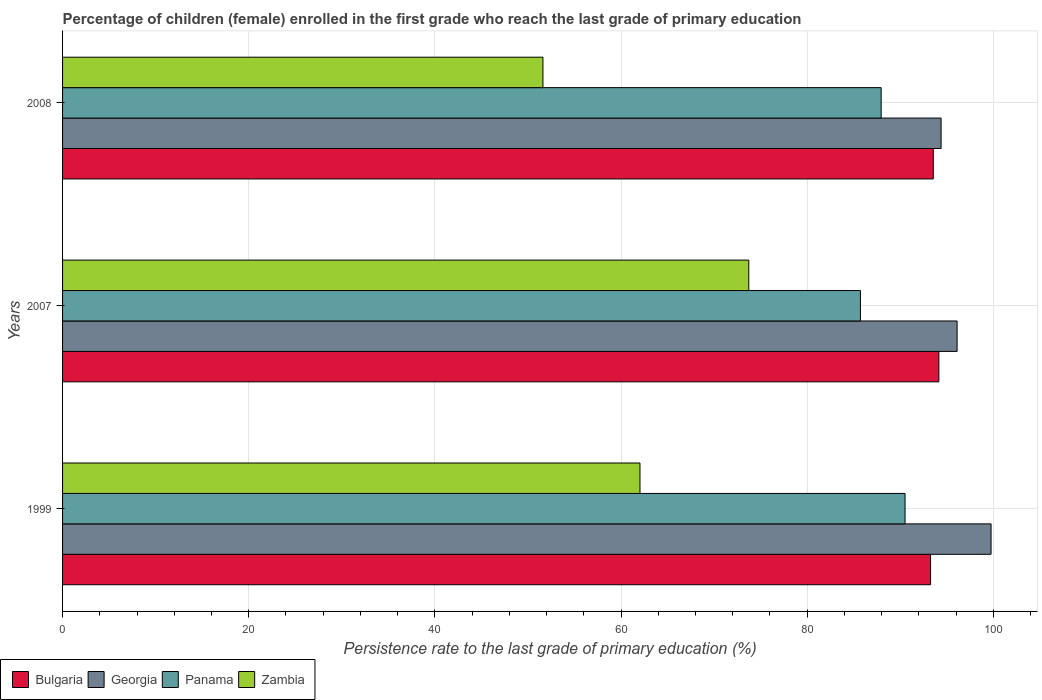How many different coloured bars are there?
Provide a short and direct response. 4. Are the number of bars on each tick of the Y-axis equal?
Ensure brevity in your answer.  Yes. How many bars are there on the 1st tick from the bottom?
Ensure brevity in your answer.  4. What is the label of the 3rd group of bars from the top?
Your answer should be compact. 1999. What is the persistence rate of children in Panama in 1999?
Give a very brief answer. 90.51. Across all years, what is the maximum persistence rate of children in Zambia?
Provide a short and direct response. 73.72. Across all years, what is the minimum persistence rate of children in Bulgaria?
Give a very brief answer. 93.25. What is the total persistence rate of children in Zambia in the graph?
Your answer should be very brief. 187.37. What is the difference between the persistence rate of children in Bulgaria in 1999 and that in 2007?
Your answer should be very brief. -0.89. What is the difference between the persistence rate of children in Bulgaria in 2008 and the persistence rate of children in Panama in 2007?
Offer a very short reply. 7.83. What is the average persistence rate of children in Zambia per year?
Offer a terse response. 62.46. In the year 1999, what is the difference between the persistence rate of children in Georgia and persistence rate of children in Panama?
Offer a very short reply. 9.24. What is the ratio of the persistence rate of children in Zambia in 2007 to that in 2008?
Provide a short and direct response. 1.43. What is the difference between the highest and the second highest persistence rate of children in Zambia?
Keep it short and to the point. 11.69. What is the difference between the highest and the lowest persistence rate of children in Panama?
Offer a terse response. 4.79. What does the 4th bar from the top in 1999 represents?
Ensure brevity in your answer.  Bulgaria. What does the 2nd bar from the bottom in 2008 represents?
Make the answer very short. Georgia. Is it the case that in every year, the sum of the persistence rate of children in Zambia and persistence rate of children in Bulgaria is greater than the persistence rate of children in Panama?
Your answer should be compact. Yes. Are all the bars in the graph horizontal?
Ensure brevity in your answer.  Yes. How many years are there in the graph?
Your response must be concise. 3. Are the values on the major ticks of X-axis written in scientific E-notation?
Provide a succinct answer. No. Does the graph contain any zero values?
Offer a very short reply. No. Does the graph contain grids?
Keep it short and to the point. Yes. Where does the legend appear in the graph?
Your response must be concise. Bottom left. How many legend labels are there?
Provide a succinct answer. 4. How are the legend labels stacked?
Provide a short and direct response. Horizontal. What is the title of the graph?
Make the answer very short. Percentage of children (female) enrolled in the first grade who reach the last grade of primary education. What is the label or title of the X-axis?
Ensure brevity in your answer.  Persistence rate to the last grade of primary education (%). What is the label or title of the Y-axis?
Offer a terse response. Years. What is the Persistence rate to the last grade of primary education (%) in Bulgaria in 1999?
Your answer should be compact. 93.25. What is the Persistence rate to the last grade of primary education (%) of Georgia in 1999?
Your answer should be compact. 99.75. What is the Persistence rate to the last grade of primary education (%) of Panama in 1999?
Ensure brevity in your answer.  90.51. What is the Persistence rate to the last grade of primary education (%) of Zambia in 1999?
Your response must be concise. 62.04. What is the Persistence rate to the last grade of primary education (%) in Bulgaria in 2007?
Offer a terse response. 94.15. What is the Persistence rate to the last grade of primary education (%) of Georgia in 2007?
Your answer should be compact. 96.1. What is the Persistence rate to the last grade of primary education (%) of Panama in 2007?
Ensure brevity in your answer.  85.72. What is the Persistence rate to the last grade of primary education (%) in Zambia in 2007?
Offer a terse response. 73.72. What is the Persistence rate to the last grade of primary education (%) in Bulgaria in 2008?
Your answer should be compact. 93.55. What is the Persistence rate to the last grade of primary education (%) of Georgia in 2008?
Your answer should be very brief. 94.38. What is the Persistence rate to the last grade of primary education (%) in Panama in 2008?
Provide a short and direct response. 87.95. What is the Persistence rate to the last grade of primary education (%) in Zambia in 2008?
Ensure brevity in your answer.  51.61. Across all years, what is the maximum Persistence rate to the last grade of primary education (%) in Bulgaria?
Your response must be concise. 94.15. Across all years, what is the maximum Persistence rate to the last grade of primary education (%) of Georgia?
Your answer should be very brief. 99.75. Across all years, what is the maximum Persistence rate to the last grade of primary education (%) of Panama?
Ensure brevity in your answer.  90.51. Across all years, what is the maximum Persistence rate to the last grade of primary education (%) of Zambia?
Ensure brevity in your answer.  73.72. Across all years, what is the minimum Persistence rate to the last grade of primary education (%) of Bulgaria?
Offer a terse response. 93.25. Across all years, what is the minimum Persistence rate to the last grade of primary education (%) in Georgia?
Your answer should be very brief. 94.38. Across all years, what is the minimum Persistence rate to the last grade of primary education (%) in Panama?
Offer a terse response. 85.72. Across all years, what is the minimum Persistence rate to the last grade of primary education (%) of Zambia?
Your response must be concise. 51.61. What is the total Persistence rate to the last grade of primary education (%) in Bulgaria in the graph?
Make the answer very short. 280.94. What is the total Persistence rate to the last grade of primary education (%) in Georgia in the graph?
Keep it short and to the point. 290.24. What is the total Persistence rate to the last grade of primary education (%) in Panama in the graph?
Keep it short and to the point. 264.18. What is the total Persistence rate to the last grade of primary education (%) of Zambia in the graph?
Your answer should be compact. 187.37. What is the difference between the Persistence rate to the last grade of primary education (%) in Bulgaria in 1999 and that in 2007?
Ensure brevity in your answer.  -0.89. What is the difference between the Persistence rate to the last grade of primary education (%) of Georgia in 1999 and that in 2007?
Your response must be concise. 3.65. What is the difference between the Persistence rate to the last grade of primary education (%) in Panama in 1999 and that in 2007?
Offer a very short reply. 4.79. What is the difference between the Persistence rate to the last grade of primary education (%) of Zambia in 1999 and that in 2007?
Your answer should be very brief. -11.69. What is the difference between the Persistence rate to the last grade of primary education (%) in Bulgaria in 1999 and that in 2008?
Make the answer very short. -0.29. What is the difference between the Persistence rate to the last grade of primary education (%) of Georgia in 1999 and that in 2008?
Provide a short and direct response. 5.37. What is the difference between the Persistence rate to the last grade of primary education (%) of Panama in 1999 and that in 2008?
Provide a succinct answer. 2.57. What is the difference between the Persistence rate to the last grade of primary education (%) in Zambia in 1999 and that in 2008?
Provide a succinct answer. 10.43. What is the difference between the Persistence rate to the last grade of primary education (%) of Bulgaria in 2007 and that in 2008?
Provide a succinct answer. 0.6. What is the difference between the Persistence rate to the last grade of primary education (%) in Georgia in 2007 and that in 2008?
Your answer should be compact. 1.72. What is the difference between the Persistence rate to the last grade of primary education (%) of Panama in 2007 and that in 2008?
Provide a succinct answer. -2.23. What is the difference between the Persistence rate to the last grade of primary education (%) in Zambia in 2007 and that in 2008?
Ensure brevity in your answer.  22.12. What is the difference between the Persistence rate to the last grade of primary education (%) in Bulgaria in 1999 and the Persistence rate to the last grade of primary education (%) in Georgia in 2007?
Provide a succinct answer. -2.85. What is the difference between the Persistence rate to the last grade of primary education (%) of Bulgaria in 1999 and the Persistence rate to the last grade of primary education (%) of Panama in 2007?
Provide a short and direct response. 7.54. What is the difference between the Persistence rate to the last grade of primary education (%) in Bulgaria in 1999 and the Persistence rate to the last grade of primary education (%) in Zambia in 2007?
Offer a terse response. 19.53. What is the difference between the Persistence rate to the last grade of primary education (%) of Georgia in 1999 and the Persistence rate to the last grade of primary education (%) of Panama in 2007?
Your response must be concise. 14.04. What is the difference between the Persistence rate to the last grade of primary education (%) in Georgia in 1999 and the Persistence rate to the last grade of primary education (%) in Zambia in 2007?
Offer a very short reply. 26.03. What is the difference between the Persistence rate to the last grade of primary education (%) in Panama in 1999 and the Persistence rate to the last grade of primary education (%) in Zambia in 2007?
Keep it short and to the point. 16.79. What is the difference between the Persistence rate to the last grade of primary education (%) of Bulgaria in 1999 and the Persistence rate to the last grade of primary education (%) of Georgia in 2008?
Your answer should be compact. -1.13. What is the difference between the Persistence rate to the last grade of primary education (%) in Bulgaria in 1999 and the Persistence rate to the last grade of primary education (%) in Panama in 2008?
Keep it short and to the point. 5.31. What is the difference between the Persistence rate to the last grade of primary education (%) in Bulgaria in 1999 and the Persistence rate to the last grade of primary education (%) in Zambia in 2008?
Your response must be concise. 41.64. What is the difference between the Persistence rate to the last grade of primary education (%) in Georgia in 1999 and the Persistence rate to the last grade of primary education (%) in Panama in 2008?
Your response must be concise. 11.81. What is the difference between the Persistence rate to the last grade of primary education (%) in Georgia in 1999 and the Persistence rate to the last grade of primary education (%) in Zambia in 2008?
Keep it short and to the point. 48.15. What is the difference between the Persistence rate to the last grade of primary education (%) in Panama in 1999 and the Persistence rate to the last grade of primary education (%) in Zambia in 2008?
Offer a very short reply. 38.9. What is the difference between the Persistence rate to the last grade of primary education (%) of Bulgaria in 2007 and the Persistence rate to the last grade of primary education (%) of Georgia in 2008?
Offer a terse response. -0.24. What is the difference between the Persistence rate to the last grade of primary education (%) in Bulgaria in 2007 and the Persistence rate to the last grade of primary education (%) in Panama in 2008?
Offer a very short reply. 6.2. What is the difference between the Persistence rate to the last grade of primary education (%) of Bulgaria in 2007 and the Persistence rate to the last grade of primary education (%) of Zambia in 2008?
Make the answer very short. 42.54. What is the difference between the Persistence rate to the last grade of primary education (%) of Georgia in 2007 and the Persistence rate to the last grade of primary education (%) of Panama in 2008?
Your answer should be very brief. 8.16. What is the difference between the Persistence rate to the last grade of primary education (%) of Georgia in 2007 and the Persistence rate to the last grade of primary education (%) of Zambia in 2008?
Provide a succinct answer. 44.5. What is the difference between the Persistence rate to the last grade of primary education (%) in Panama in 2007 and the Persistence rate to the last grade of primary education (%) in Zambia in 2008?
Keep it short and to the point. 34.11. What is the average Persistence rate to the last grade of primary education (%) of Bulgaria per year?
Keep it short and to the point. 93.65. What is the average Persistence rate to the last grade of primary education (%) in Georgia per year?
Keep it short and to the point. 96.75. What is the average Persistence rate to the last grade of primary education (%) of Panama per year?
Provide a succinct answer. 88.06. What is the average Persistence rate to the last grade of primary education (%) of Zambia per year?
Your answer should be very brief. 62.46. In the year 1999, what is the difference between the Persistence rate to the last grade of primary education (%) of Bulgaria and Persistence rate to the last grade of primary education (%) of Georgia?
Ensure brevity in your answer.  -6.5. In the year 1999, what is the difference between the Persistence rate to the last grade of primary education (%) of Bulgaria and Persistence rate to the last grade of primary education (%) of Panama?
Provide a succinct answer. 2.74. In the year 1999, what is the difference between the Persistence rate to the last grade of primary education (%) of Bulgaria and Persistence rate to the last grade of primary education (%) of Zambia?
Ensure brevity in your answer.  31.22. In the year 1999, what is the difference between the Persistence rate to the last grade of primary education (%) in Georgia and Persistence rate to the last grade of primary education (%) in Panama?
Keep it short and to the point. 9.24. In the year 1999, what is the difference between the Persistence rate to the last grade of primary education (%) in Georgia and Persistence rate to the last grade of primary education (%) in Zambia?
Keep it short and to the point. 37.72. In the year 1999, what is the difference between the Persistence rate to the last grade of primary education (%) in Panama and Persistence rate to the last grade of primary education (%) in Zambia?
Offer a terse response. 28.48. In the year 2007, what is the difference between the Persistence rate to the last grade of primary education (%) of Bulgaria and Persistence rate to the last grade of primary education (%) of Georgia?
Ensure brevity in your answer.  -1.96. In the year 2007, what is the difference between the Persistence rate to the last grade of primary education (%) of Bulgaria and Persistence rate to the last grade of primary education (%) of Panama?
Provide a succinct answer. 8.43. In the year 2007, what is the difference between the Persistence rate to the last grade of primary education (%) of Bulgaria and Persistence rate to the last grade of primary education (%) of Zambia?
Keep it short and to the point. 20.42. In the year 2007, what is the difference between the Persistence rate to the last grade of primary education (%) of Georgia and Persistence rate to the last grade of primary education (%) of Panama?
Make the answer very short. 10.39. In the year 2007, what is the difference between the Persistence rate to the last grade of primary education (%) in Georgia and Persistence rate to the last grade of primary education (%) in Zambia?
Your answer should be very brief. 22.38. In the year 2007, what is the difference between the Persistence rate to the last grade of primary education (%) of Panama and Persistence rate to the last grade of primary education (%) of Zambia?
Your answer should be very brief. 11.99. In the year 2008, what is the difference between the Persistence rate to the last grade of primary education (%) of Bulgaria and Persistence rate to the last grade of primary education (%) of Georgia?
Make the answer very short. -0.84. In the year 2008, what is the difference between the Persistence rate to the last grade of primary education (%) of Bulgaria and Persistence rate to the last grade of primary education (%) of Panama?
Give a very brief answer. 5.6. In the year 2008, what is the difference between the Persistence rate to the last grade of primary education (%) in Bulgaria and Persistence rate to the last grade of primary education (%) in Zambia?
Provide a succinct answer. 41.94. In the year 2008, what is the difference between the Persistence rate to the last grade of primary education (%) of Georgia and Persistence rate to the last grade of primary education (%) of Panama?
Offer a very short reply. 6.44. In the year 2008, what is the difference between the Persistence rate to the last grade of primary education (%) of Georgia and Persistence rate to the last grade of primary education (%) of Zambia?
Your response must be concise. 42.78. In the year 2008, what is the difference between the Persistence rate to the last grade of primary education (%) in Panama and Persistence rate to the last grade of primary education (%) in Zambia?
Your answer should be compact. 36.34. What is the ratio of the Persistence rate to the last grade of primary education (%) in Georgia in 1999 to that in 2007?
Offer a terse response. 1.04. What is the ratio of the Persistence rate to the last grade of primary education (%) of Panama in 1999 to that in 2007?
Provide a short and direct response. 1.06. What is the ratio of the Persistence rate to the last grade of primary education (%) of Zambia in 1999 to that in 2007?
Make the answer very short. 0.84. What is the ratio of the Persistence rate to the last grade of primary education (%) in Bulgaria in 1999 to that in 2008?
Your answer should be very brief. 1. What is the ratio of the Persistence rate to the last grade of primary education (%) in Georgia in 1999 to that in 2008?
Your answer should be compact. 1.06. What is the ratio of the Persistence rate to the last grade of primary education (%) of Panama in 1999 to that in 2008?
Provide a short and direct response. 1.03. What is the ratio of the Persistence rate to the last grade of primary education (%) of Zambia in 1999 to that in 2008?
Offer a very short reply. 1.2. What is the ratio of the Persistence rate to the last grade of primary education (%) of Bulgaria in 2007 to that in 2008?
Your response must be concise. 1.01. What is the ratio of the Persistence rate to the last grade of primary education (%) in Georgia in 2007 to that in 2008?
Provide a succinct answer. 1.02. What is the ratio of the Persistence rate to the last grade of primary education (%) of Panama in 2007 to that in 2008?
Your answer should be compact. 0.97. What is the ratio of the Persistence rate to the last grade of primary education (%) of Zambia in 2007 to that in 2008?
Offer a very short reply. 1.43. What is the difference between the highest and the second highest Persistence rate to the last grade of primary education (%) of Bulgaria?
Provide a short and direct response. 0.6. What is the difference between the highest and the second highest Persistence rate to the last grade of primary education (%) in Georgia?
Your answer should be compact. 3.65. What is the difference between the highest and the second highest Persistence rate to the last grade of primary education (%) in Panama?
Provide a succinct answer. 2.57. What is the difference between the highest and the second highest Persistence rate to the last grade of primary education (%) in Zambia?
Make the answer very short. 11.69. What is the difference between the highest and the lowest Persistence rate to the last grade of primary education (%) in Bulgaria?
Your answer should be very brief. 0.89. What is the difference between the highest and the lowest Persistence rate to the last grade of primary education (%) in Georgia?
Offer a terse response. 5.37. What is the difference between the highest and the lowest Persistence rate to the last grade of primary education (%) of Panama?
Keep it short and to the point. 4.79. What is the difference between the highest and the lowest Persistence rate to the last grade of primary education (%) in Zambia?
Provide a short and direct response. 22.12. 